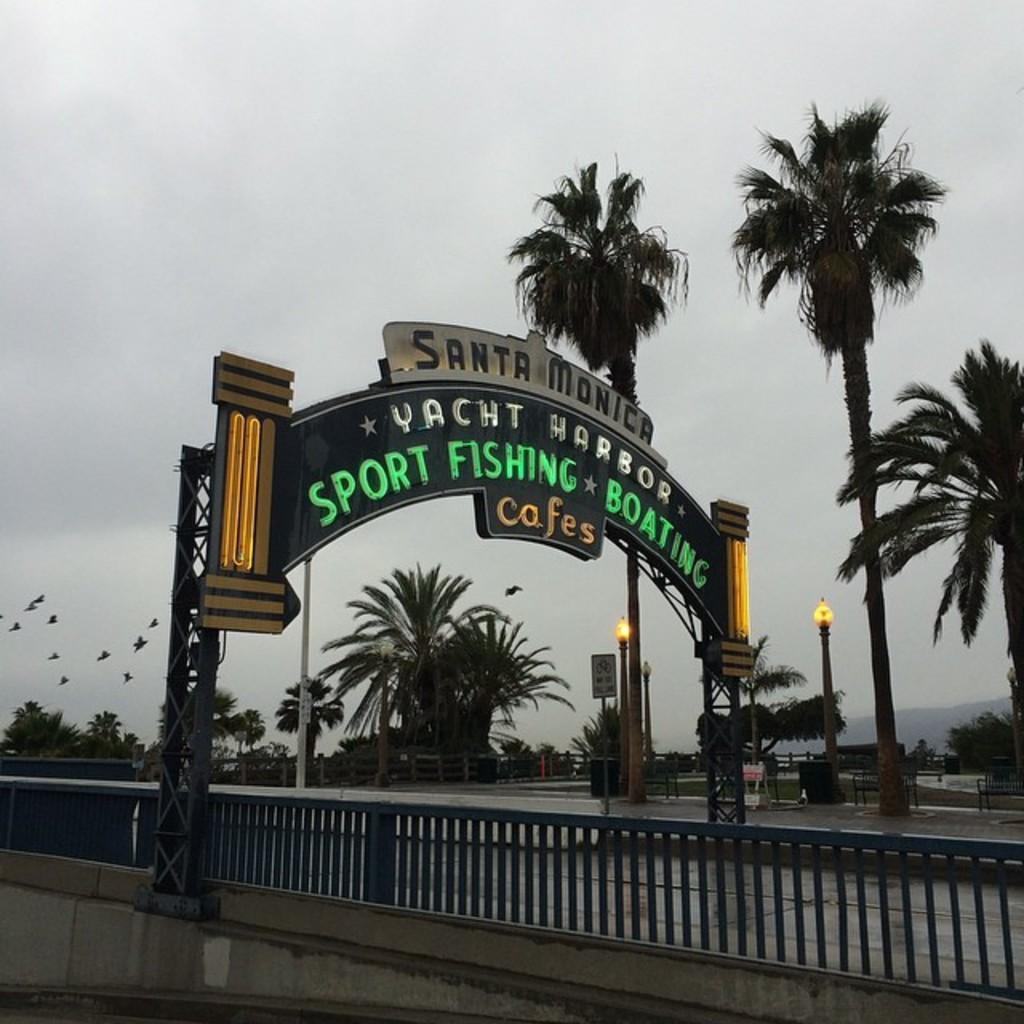Can you describe this image briefly? Here we can see arch and fence. Something written on this arch. Background there are trees, sky, light poles, board and fence. Birds are flying in the air. Sky is cloudy.  